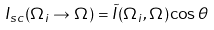Convert formula to latex. <formula><loc_0><loc_0><loc_500><loc_500>I _ { s c } ( \Omega _ { i } \rightarrow \Omega ) = \tilde { I } ( \Omega _ { i } , \Omega ) \cos \theta</formula> 